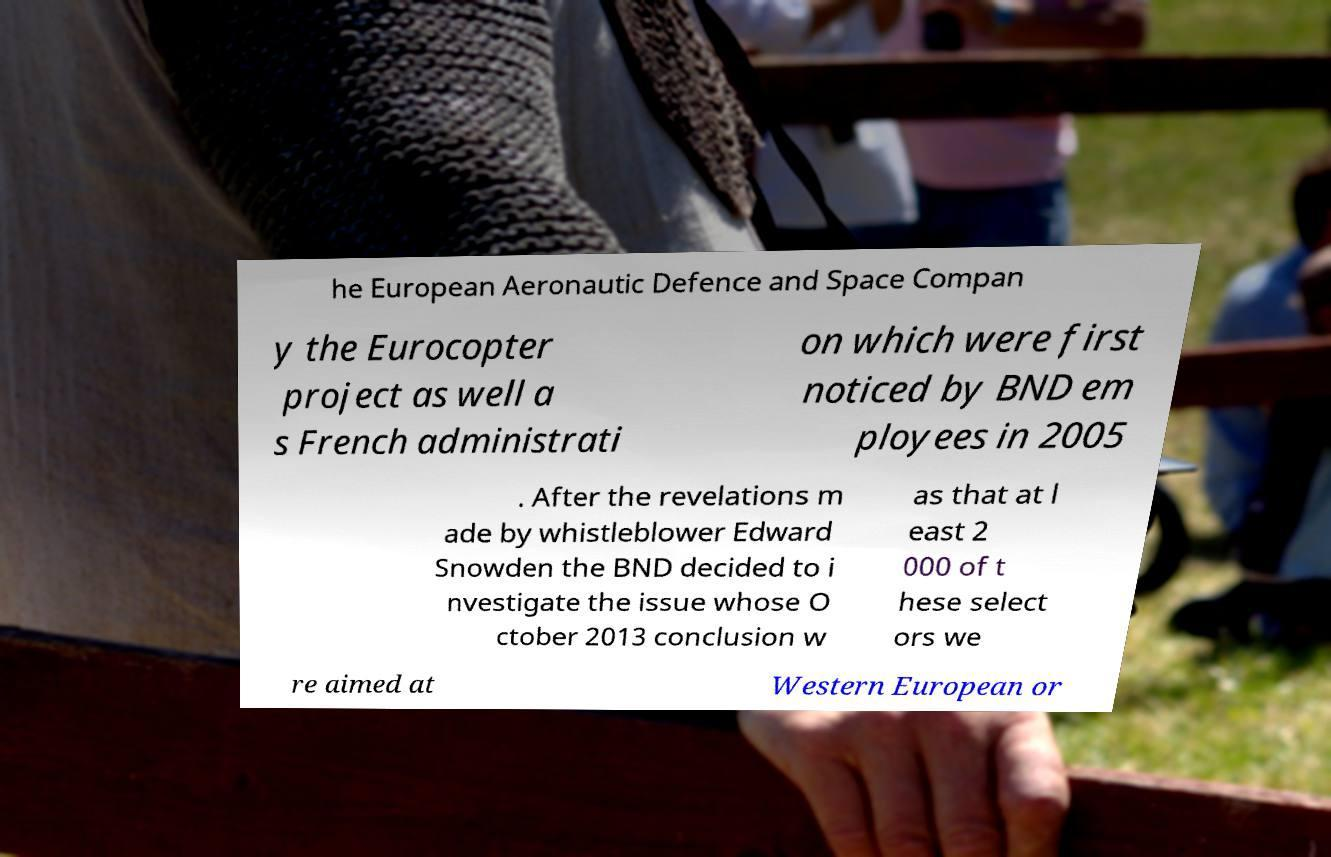Could you extract and type out the text from this image? he European Aeronautic Defence and Space Compan y the Eurocopter project as well a s French administrati on which were first noticed by BND em ployees in 2005 . After the revelations m ade by whistleblower Edward Snowden the BND decided to i nvestigate the issue whose O ctober 2013 conclusion w as that at l east 2 000 of t hese select ors we re aimed at Western European or 